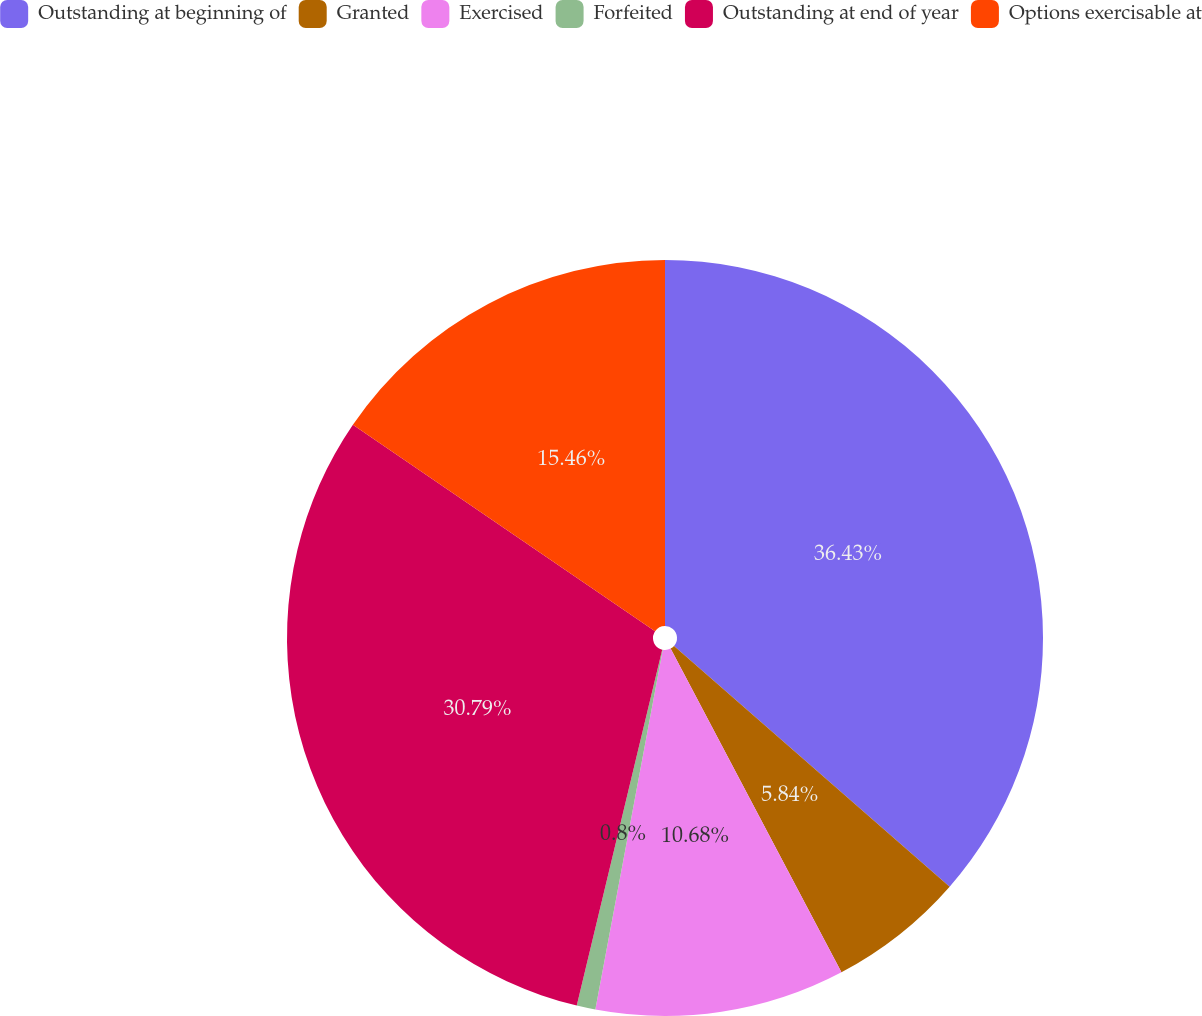<chart> <loc_0><loc_0><loc_500><loc_500><pie_chart><fcel>Outstanding at beginning of<fcel>Granted<fcel>Exercised<fcel>Forfeited<fcel>Outstanding at end of year<fcel>Options exercisable at<nl><fcel>36.43%<fcel>5.84%<fcel>10.68%<fcel>0.8%<fcel>30.79%<fcel>15.46%<nl></chart> 